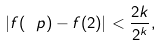Convert formula to latex. <formula><loc_0><loc_0><loc_500><loc_500>| f ( \ p ) - f ( 2 ) | < \frac { 2 k } { 2 ^ { k } } ,</formula> 